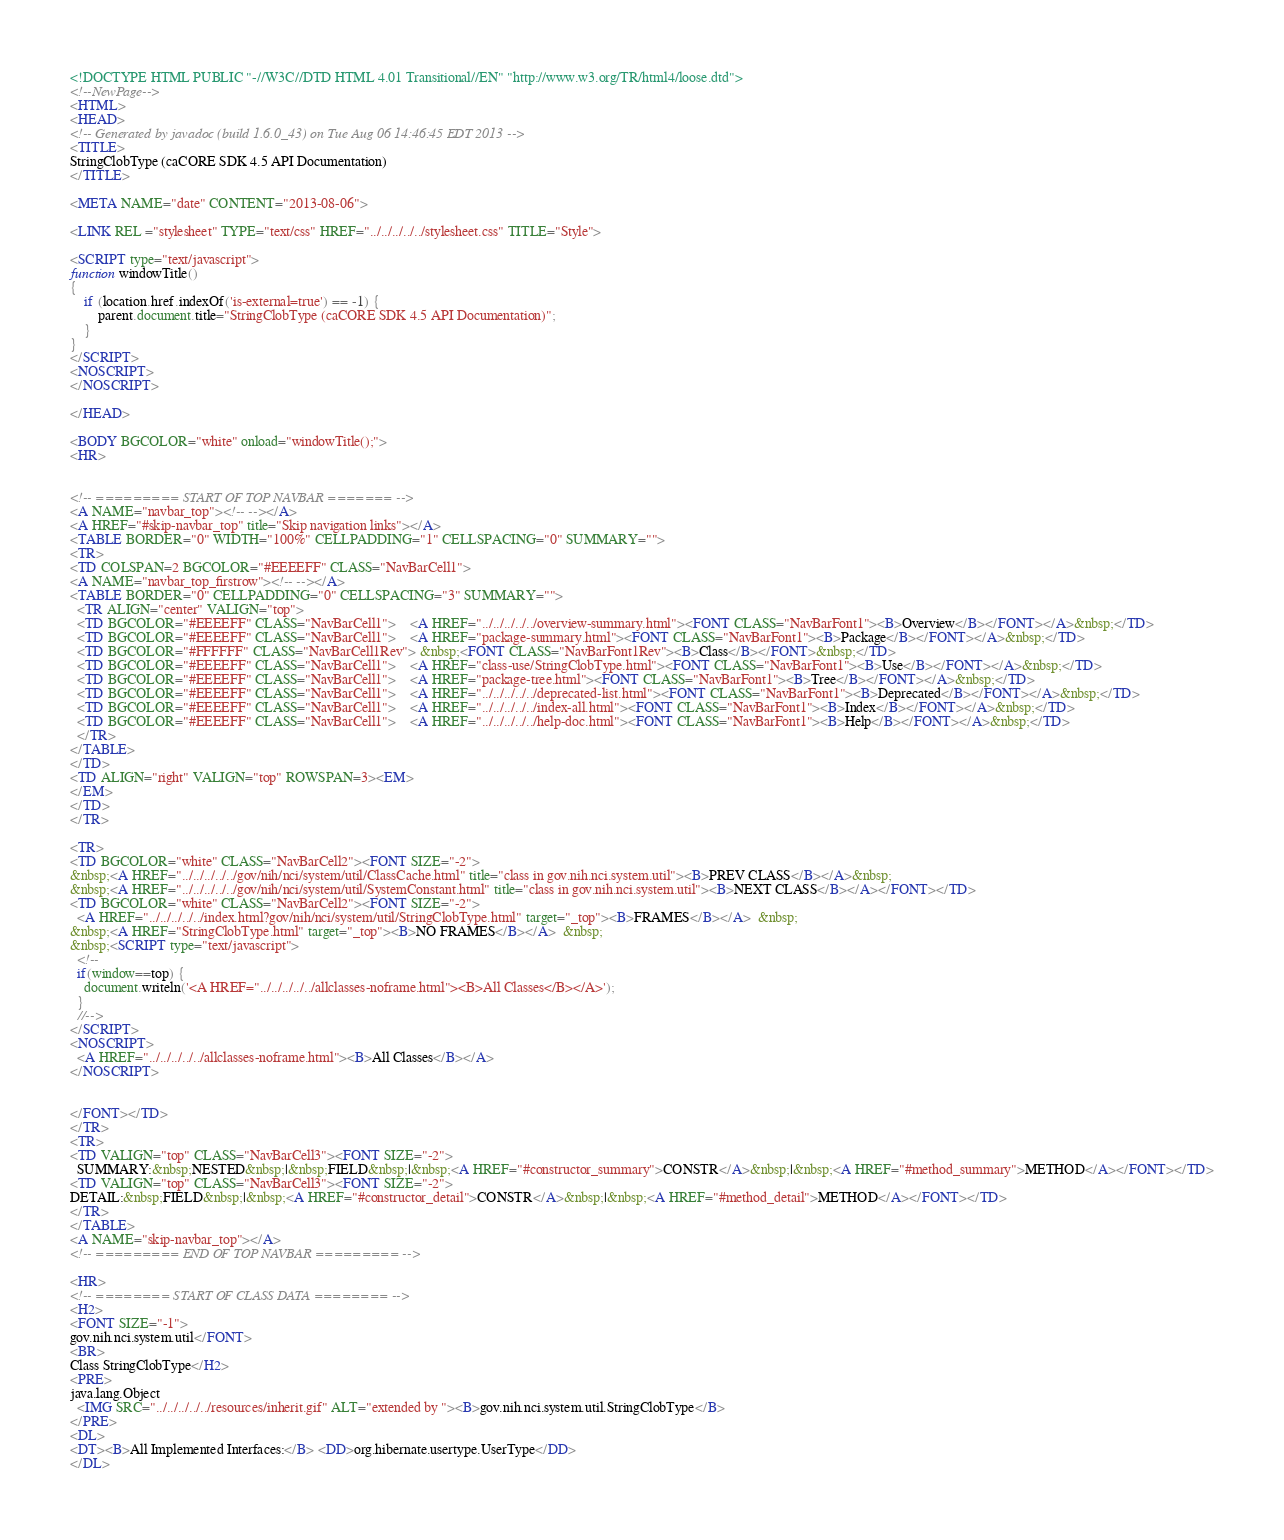Convert code to text. <code><loc_0><loc_0><loc_500><loc_500><_HTML_><!DOCTYPE HTML PUBLIC "-//W3C//DTD HTML 4.01 Transitional//EN" "http://www.w3.org/TR/html4/loose.dtd">
<!--NewPage-->
<HTML>
<HEAD>
<!-- Generated by javadoc (build 1.6.0_43) on Tue Aug 06 14:46:45 EDT 2013 -->
<TITLE>
StringClobType (caCORE SDK 4.5 API Documentation)
</TITLE>

<META NAME="date" CONTENT="2013-08-06">

<LINK REL ="stylesheet" TYPE="text/css" HREF="../../../../../stylesheet.css" TITLE="Style">

<SCRIPT type="text/javascript">
function windowTitle()
{
    if (location.href.indexOf('is-external=true') == -1) {
        parent.document.title="StringClobType (caCORE SDK 4.5 API Documentation)";
    }
}
</SCRIPT>
<NOSCRIPT>
</NOSCRIPT>

</HEAD>

<BODY BGCOLOR="white" onload="windowTitle();">
<HR>


<!-- ========= START OF TOP NAVBAR ======= -->
<A NAME="navbar_top"><!-- --></A>
<A HREF="#skip-navbar_top" title="Skip navigation links"></A>
<TABLE BORDER="0" WIDTH="100%" CELLPADDING="1" CELLSPACING="0" SUMMARY="">
<TR>
<TD COLSPAN=2 BGCOLOR="#EEEEFF" CLASS="NavBarCell1">
<A NAME="navbar_top_firstrow"><!-- --></A>
<TABLE BORDER="0" CELLPADDING="0" CELLSPACING="3" SUMMARY="">
  <TR ALIGN="center" VALIGN="top">
  <TD BGCOLOR="#EEEEFF" CLASS="NavBarCell1">    <A HREF="../../../../../overview-summary.html"><FONT CLASS="NavBarFont1"><B>Overview</B></FONT></A>&nbsp;</TD>
  <TD BGCOLOR="#EEEEFF" CLASS="NavBarCell1">    <A HREF="package-summary.html"><FONT CLASS="NavBarFont1"><B>Package</B></FONT></A>&nbsp;</TD>
  <TD BGCOLOR="#FFFFFF" CLASS="NavBarCell1Rev"> &nbsp;<FONT CLASS="NavBarFont1Rev"><B>Class</B></FONT>&nbsp;</TD>
  <TD BGCOLOR="#EEEEFF" CLASS="NavBarCell1">    <A HREF="class-use/StringClobType.html"><FONT CLASS="NavBarFont1"><B>Use</B></FONT></A>&nbsp;</TD>
  <TD BGCOLOR="#EEEEFF" CLASS="NavBarCell1">    <A HREF="package-tree.html"><FONT CLASS="NavBarFont1"><B>Tree</B></FONT></A>&nbsp;</TD>
  <TD BGCOLOR="#EEEEFF" CLASS="NavBarCell1">    <A HREF="../../../../../deprecated-list.html"><FONT CLASS="NavBarFont1"><B>Deprecated</B></FONT></A>&nbsp;</TD>
  <TD BGCOLOR="#EEEEFF" CLASS="NavBarCell1">    <A HREF="../../../../../index-all.html"><FONT CLASS="NavBarFont1"><B>Index</B></FONT></A>&nbsp;</TD>
  <TD BGCOLOR="#EEEEFF" CLASS="NavBarCell1">    <A HREF="../../../../../help-doc.html"><FONT CLASS="NavBarFont1"><B>Help</B></FONT></A>&nbsp;</TD>
  </TR>
</TABLE>
</TD>
<TD ALIGN="right" VALIGN="top" ROWSPAN=3><EM>
</EM>
</TD>
</TR>

<TR>
<TD BGCOLOR="white" CLASS="NavBarCell2"><FONT SIZE="-2">
&nbsp;<A HREF="../../../../../gov/nih/nci/system/util/ClassCache.html" title="class in gov.nih.nci.system.util"><B>PREV CLASS</B></A>&nbsp;
&nbsp;<A HREF="../../../../../gov/nih/nci/system/util/SystemConstant.html" title="class in gov.nih.nci.system.util"><B>NEXT CLASS</B></A></FONT></TD>
<TD BGCOLOR="white" CLASS="NavBarCell2"><FONT SIZE="-2">
  <A HREF="../../../../../index.html?gov/nih/nci/system/util/StringClobType.html" target="_top"><B>FRAMES</B></A>  &nbsp;
&nbsp;<A HREF="StringClobType.html" target="_top"><B>NO FRAMES</B></A>  &nbsp;
&nbsp;<SCRIPT type="text/javascript">
  <!--
  if(window==top) {
    document.writeln('<A HREF="../../../../../allclasses-noframe.html"><B>All Classes</B></A>');
  }
  //-->
</SCRIPT>
<NOSCRIPT>
  <A HREF="../../../../../allclasses-noframe.html"><B>All Classes</B></A>
</NOSCRIPT>


</FONT></TD>
</TR>
<TR>
<TD VALIGN="top" CLASS="NavBarCell3"><FONT SIZE="-2">
  SUMMARY:&nbsp;NESTED&nbsp;|&nbsp;FIELD&nbsp;|&nbsp;<A HREF="#constructor_summary">CONSTR</A>&nbsp;|&nbsp;<A HREF="#method_summary">METHOD</A></FONT></TD>
<TD VALIGN="top" CLASS="NavBarCell3"><FONT SIZE="-2">
DETAIL:&nbsp;FIELD&nbsp;|&nbsp;<A HREF="#constructor_detail">CONSTR</A>&nbsp;|&nbsp;<A HREF="#method_detail">METHOD</A></FONT></TD>
</TR>
</TABLE>
<A NAME="skip-navbar_top"></A>
<!-- ========= END OF TOP NAVBAR ========= -->

<HR>
<!-- ======== START OF CLASS DATA ======== -->
<H2>
<FONT SIZE="-1">
gov.nih.nci.system.util</FONT>
<BR>
Class StringClobType</H2>
<PRE>
java.lang.Object
  <IMG SRC="../../../../../resources/inherit.gif" ALT="extended by "><B>gov.nih.nci.system.util.StringClobType</B>
</PRE>
<DL>
<DT><B>All Implemented Interfaces:</B> <DD>org.hibernate.usertype.UserType</DD>
</DL></code> 